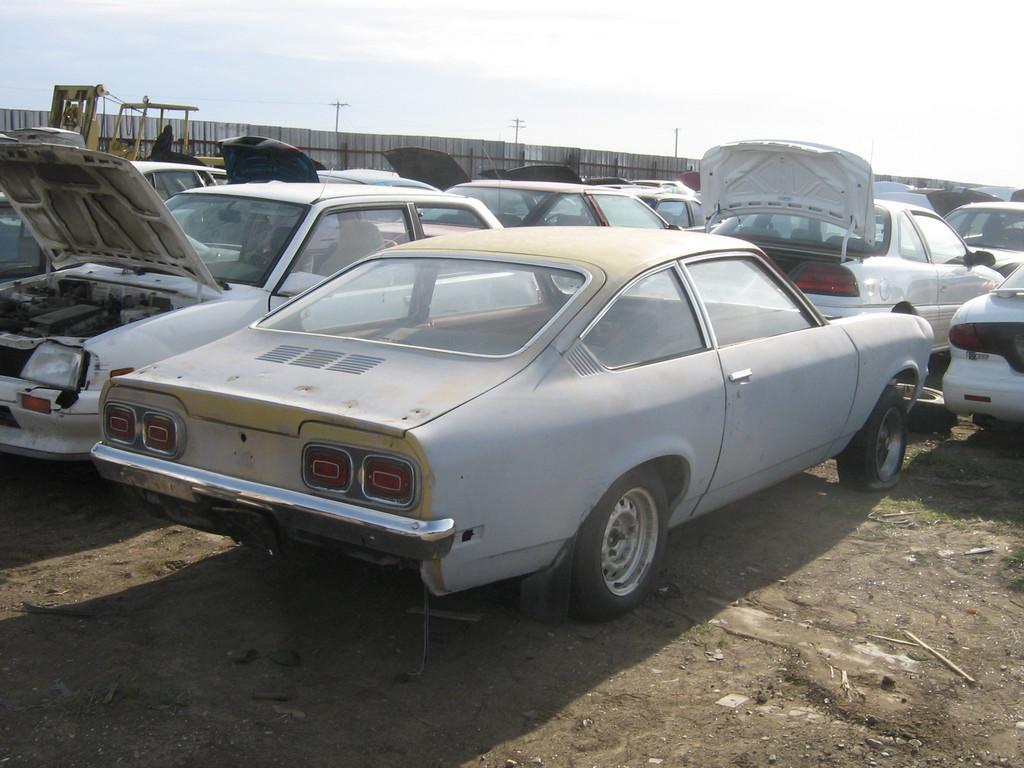In one or two sentences, can you explain what this image depicts? In this picture we can see cars on the ground, fence, poles, grass and some objects and in the background we can see the sky. 